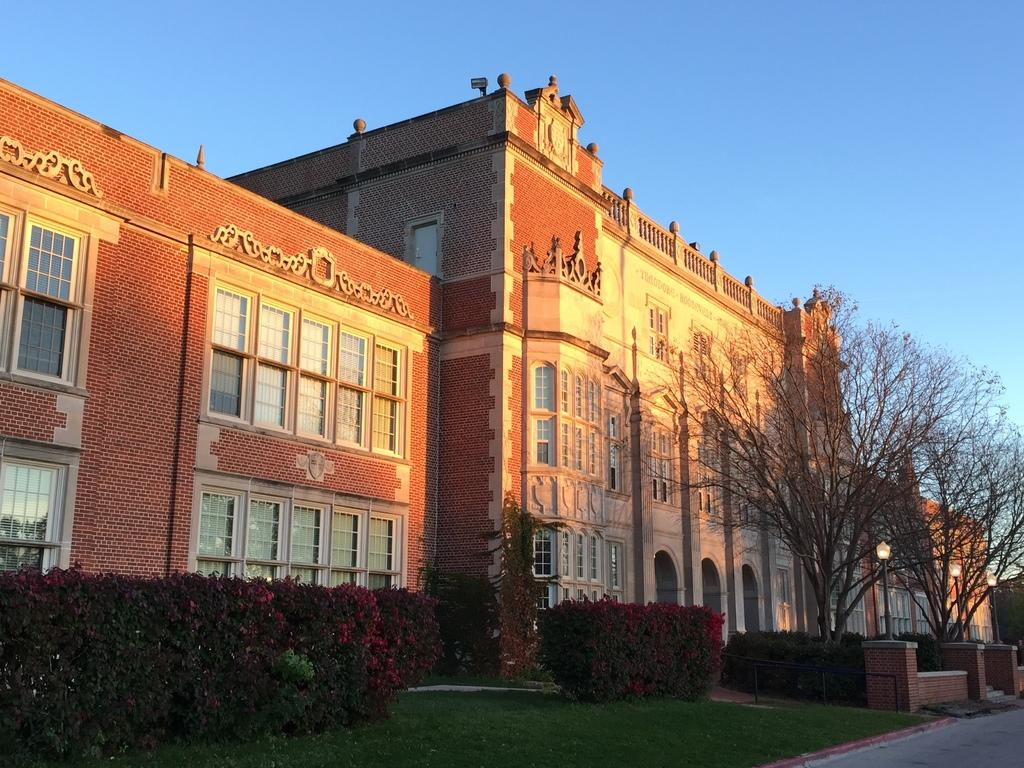What type of vegetation is present in the image? There is grass in the image. What type of container is visible in the image? There is a planter in the image. What type of structures are present in the image? There are light poles and railing in the image. What type of man-made structure is visible in the image? There is a building in the image. What type of natural vegetation is present in the image? There are trees in the image. What can be seen in the background of the image? The sky is visible in the background of the image, and it is blue in color. What type of butter is being used to grease the plantation in the image? There is no butter or plantation present in the image. How does the heat affect the plants in the image? There is no indication of heat or its effects on plants in the image. 